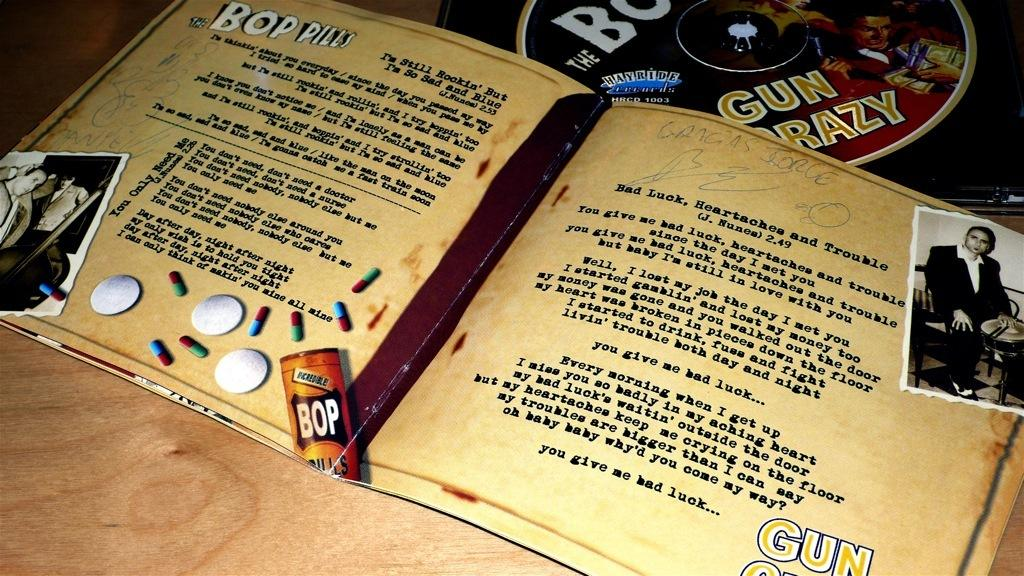<image>
Summarize the visual content of the image. Liner notes for a Bop Pills CD are open and laying on a table by the disc. 